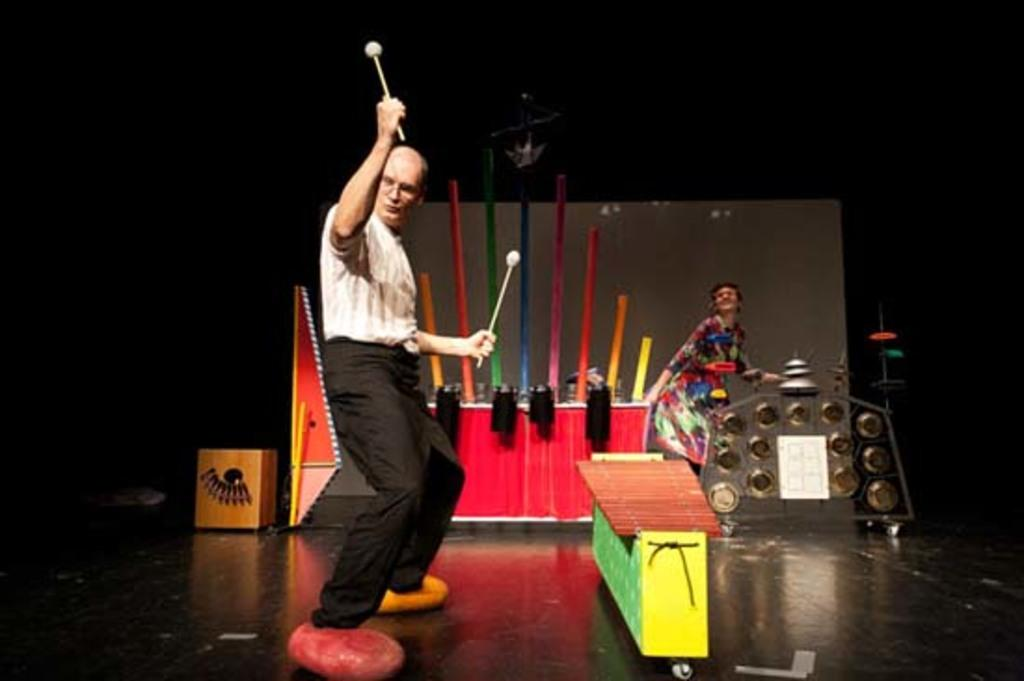What is happening on the stage in the image? There are artists performing on the stage. What colors can be seen in the image? There are objects with various colors (yellow, red, pink, and blue) in the image. What is the color of the curtain in the image? The curtain in the image is white in color. Are there any bushes growing on top of the stage in the image? There are no bushes visible in the image, and the stage does not appear to have any plants growing on it. Is there a war happening in the image? There is no indication of a war or any conflict in the image; it shows artists performing on a stage. 